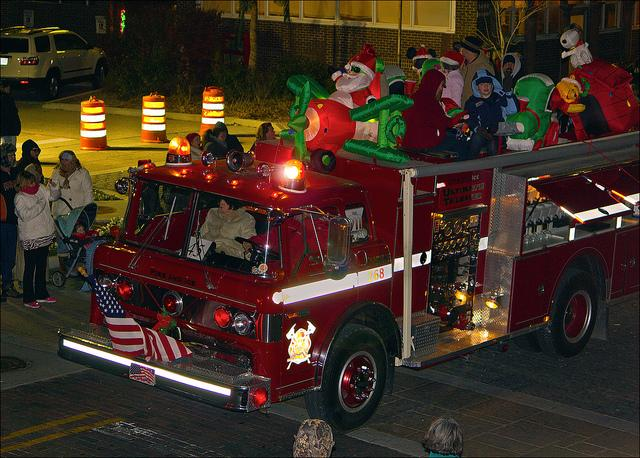What sort of Holiday parade is being feted here? Please explain your reasoning. christmas. Christmas decorations are on the truck. 